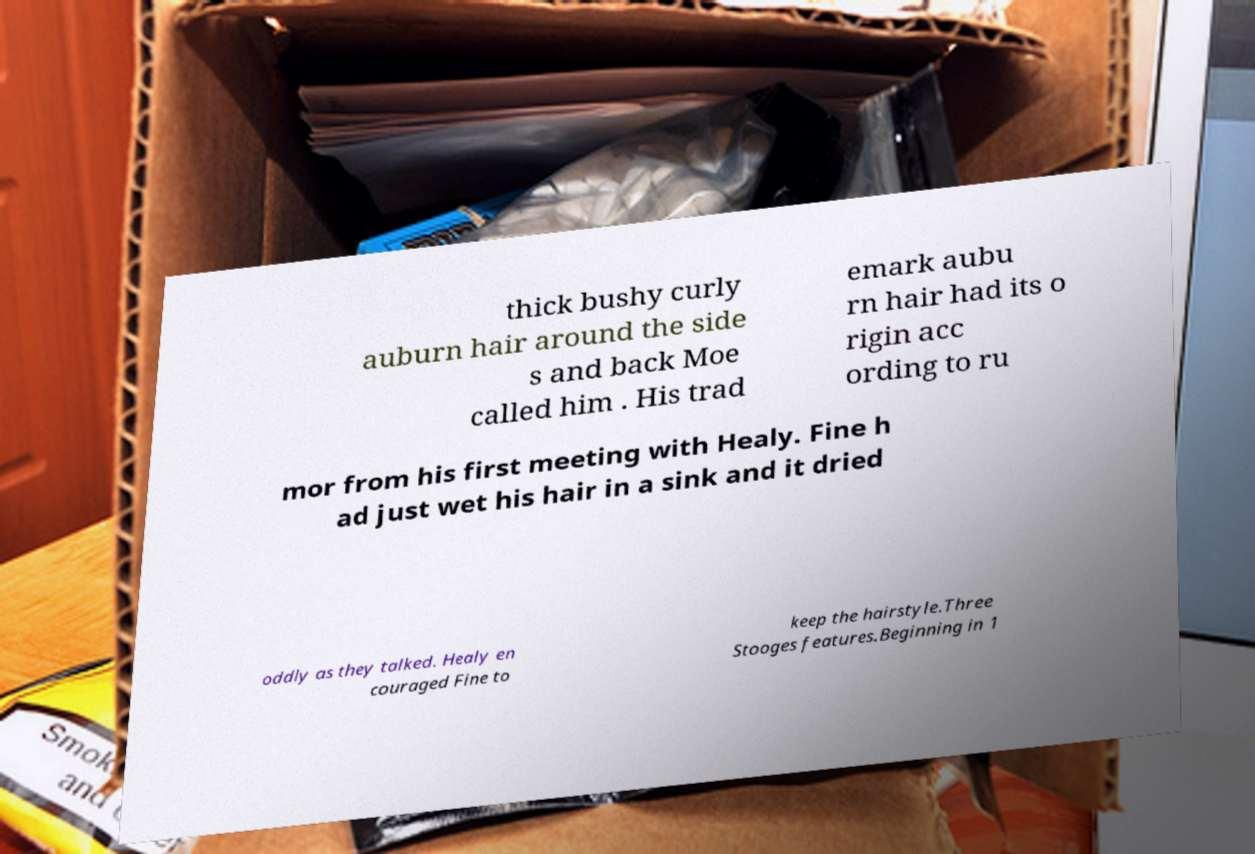Can you accurately transcribe the text from the provided image for me? thick bushy curly auburn hair around the side s and back Moe called him . His trad emark aubu rn hair had its o rigin acc ording to ru mor from his first meeting with Healy. Fine h ad just wet his hair in a sink and it dried oddly as they talked. Healy en couraged Fine to keep the hairstyle.Three Stooges features.Beginning in 1 